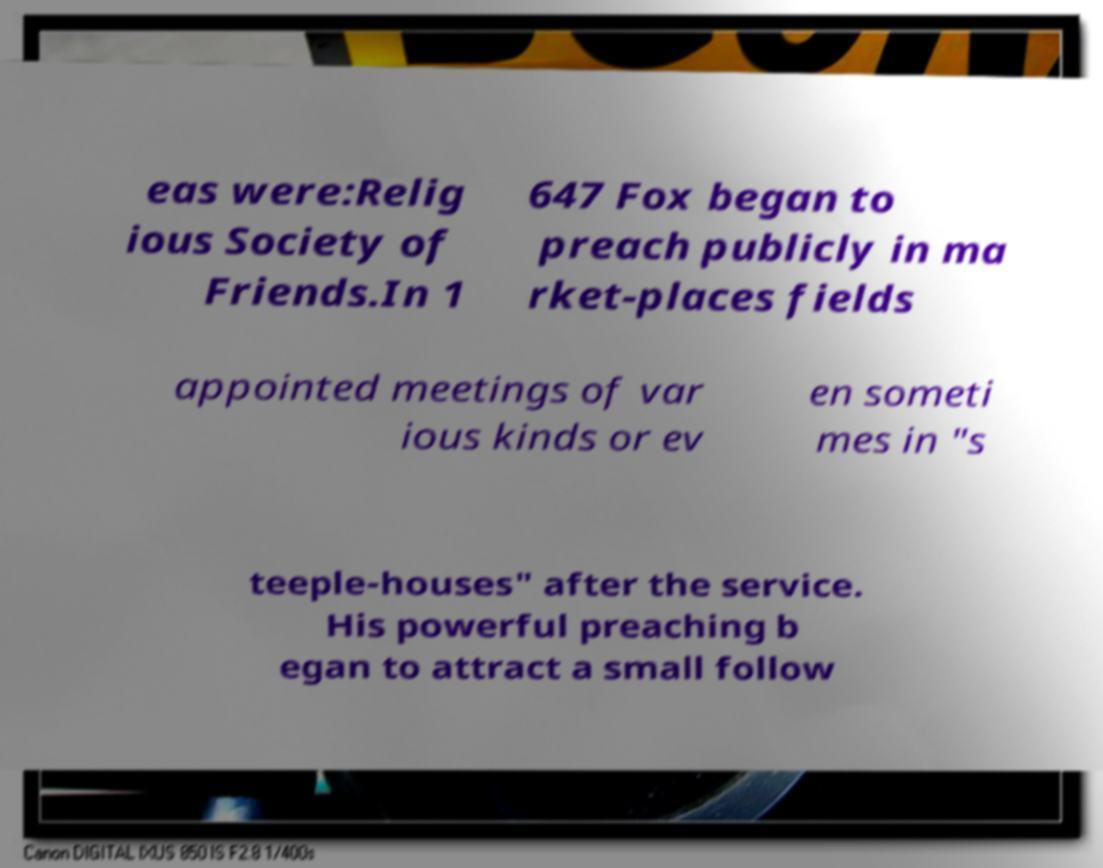I need the written content from this picture converted into text. Can you do that? eas were:Relig ious Society of Friends.In 1 647 Fox began to preach publicly in ma rket-places fields appointed meetings of var ious kinds or ev en someti mes in "s teeple-houses" after the service. His powerful preaching b egan to attract a small follow 